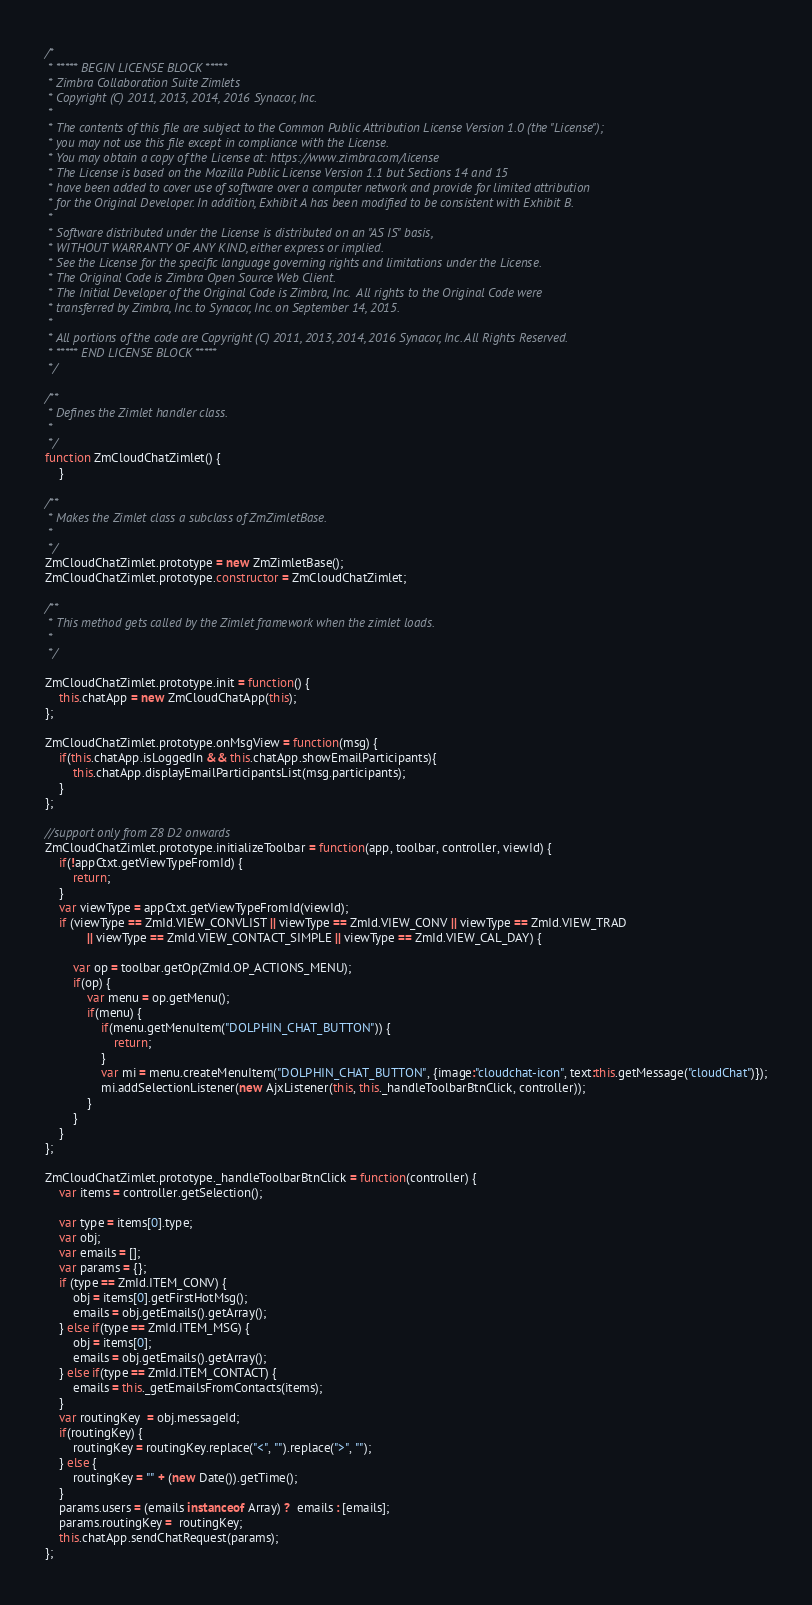<code> <loc_0><loc_0><loc_500><loc_500><_JavaScript_>/*
 * ***** BEGIN LICENSE BLOCK *****
 * Zimbra Collaboration Suite Zimlets
 * Copyright (C) 2011, 2013, 2014, 2016 Synacor, Inc.
 *
 * The contents of this file are subject to the Common Public Attribution License Version 1.0 (the "License");
 * you may not use this file except in compliance with the License.
 * You may obtain a copy of the License at: https://www.zimbra.com/license
 * The License is based on the Mozilla Public License Version 1.1 but Sections 14 and 15
 * have been added to cover use of software over a computer network and provide for limited attribution
 * for the Original Developer. In addition, Exhibit A has been modified to be consistent with Exhibit B.
 *
 * Software distributed under the License is distributed on an "AS IS" basis,
 * WITHOUT WARRANTY OF ANY KIND, either express or implied.
 * See the License for the specific language governing rights and limitations under the License.
 * The Original Code is Zimbra Open Source Web Client.
 * The Initial Developer of the Original Code is Zimbra, Inc.  All rights to the Original Code were
 * transferred by Zimbra, Inc. to Synacor, Inc. on September 14, 2015.
 *
 * All portions of the code are Copyright (C) 2011, 2013, 2014, 2016 Synacor, Inc. All Rights Reserved.
 * ***** END LICENSE BLOCK *****
 */

/**
 * Defines the Zimlet handler class.
 * 
 */
function ZmCloudChatZimlet() {
    }

/**
 * Makes the Zimlet class a subclass of ZmZimletBase.
 * 
 */
ZmCloudChatZimlet.prototype = new ZmZimletBase();
ZmCloudChatZimlet.prototype.constructor = ZmCloudChatZimlet;

/**
 * This method gets called by the Zimlet framework when the zimlet loads.
 * 
 */

ZmCloudChatZimlet.prototype.init = function() {
    this.chatApp = new ZmCloudChatApp(this);
};

ZmCloudChatZimlet.prototype.onMsgView = function(msg) {
	if(this.chatApp.isLoggedIn && this.chatApp.showEmailParticipants){
		this.chatApp.displayEmailParticipantsList(msg.participants);
	}
};

//support only from Z8 D2 onwards
ZmCloudChatZimlet.prototype.initializeToolbar = function(app, toolbar, controller, viewId) {
	if(!appCtxt.getViewTypeFromId) {
		return;
	}
	var viewType = appCtxt.getViewTypeFromId(viewId);
	if (viewType == ZmId.VIEW_CONVLIST || viewType == ZmId.VIEW_CONV || viewType == ZmId.VIEW_TRAD
			|| viewType == ZmId.VIEW_CONTACT_SIMPLE || viewType == ZmId.VIEW_CAL_DAY) {

		var op = toolbar.getOp(ZmId.OP_ACTIONS_MENU);
		if(op) {
			var menu = op.getMenu();
			if(menu) {
				if(menu.getMenuItem("DOLPHIN_CHAT_BUTTON")) {
					return;
				}
				var mi = menu.createMenuItem("DOLPHIN_CHAT_BUTTON", {image:"cloudchat-icon", text:this.getMessage("cloudChat")});
				mi.addSelectionListener(new AjxListener(this, this._handleToolbarBtnClick, controller));
			}
		}
	}
};

ZmCloudChatZimlet.prototype._handleToolbarBtnClick = function(controller) {
 	var items = controller.getSelection();

	var type = items[0].type;
	var obj;
	var emails = [];
	var params = {};
	if (type == ZmId.ITEM_CONV) {
		obj = items[0].getFirstHotMsg();
		emails = obj.getEmails().getArray();
	} else if(type == ZmId.ITEM_MSG) {
		obj = items[0];
		emails = obj.getEmails().getArray();
	} else if(type == ZmId.ITEM_CONTACT) {
		emails = this._getEmailsFromContacts(items);
	}
	var routingKey  = obj.messageId;
	if(routingKey) {
		routingKey = routingKey.replace("<", "").replace(">", "");
	} else {
		routingKey = "" + (new Date()).getTime();
	}
	params.users = (emails instanceof Array) ?  emails : [emails];
	params.routingKey =  routingKey;
	this.chatApp.sendChatRequest(params);
};


</code> 